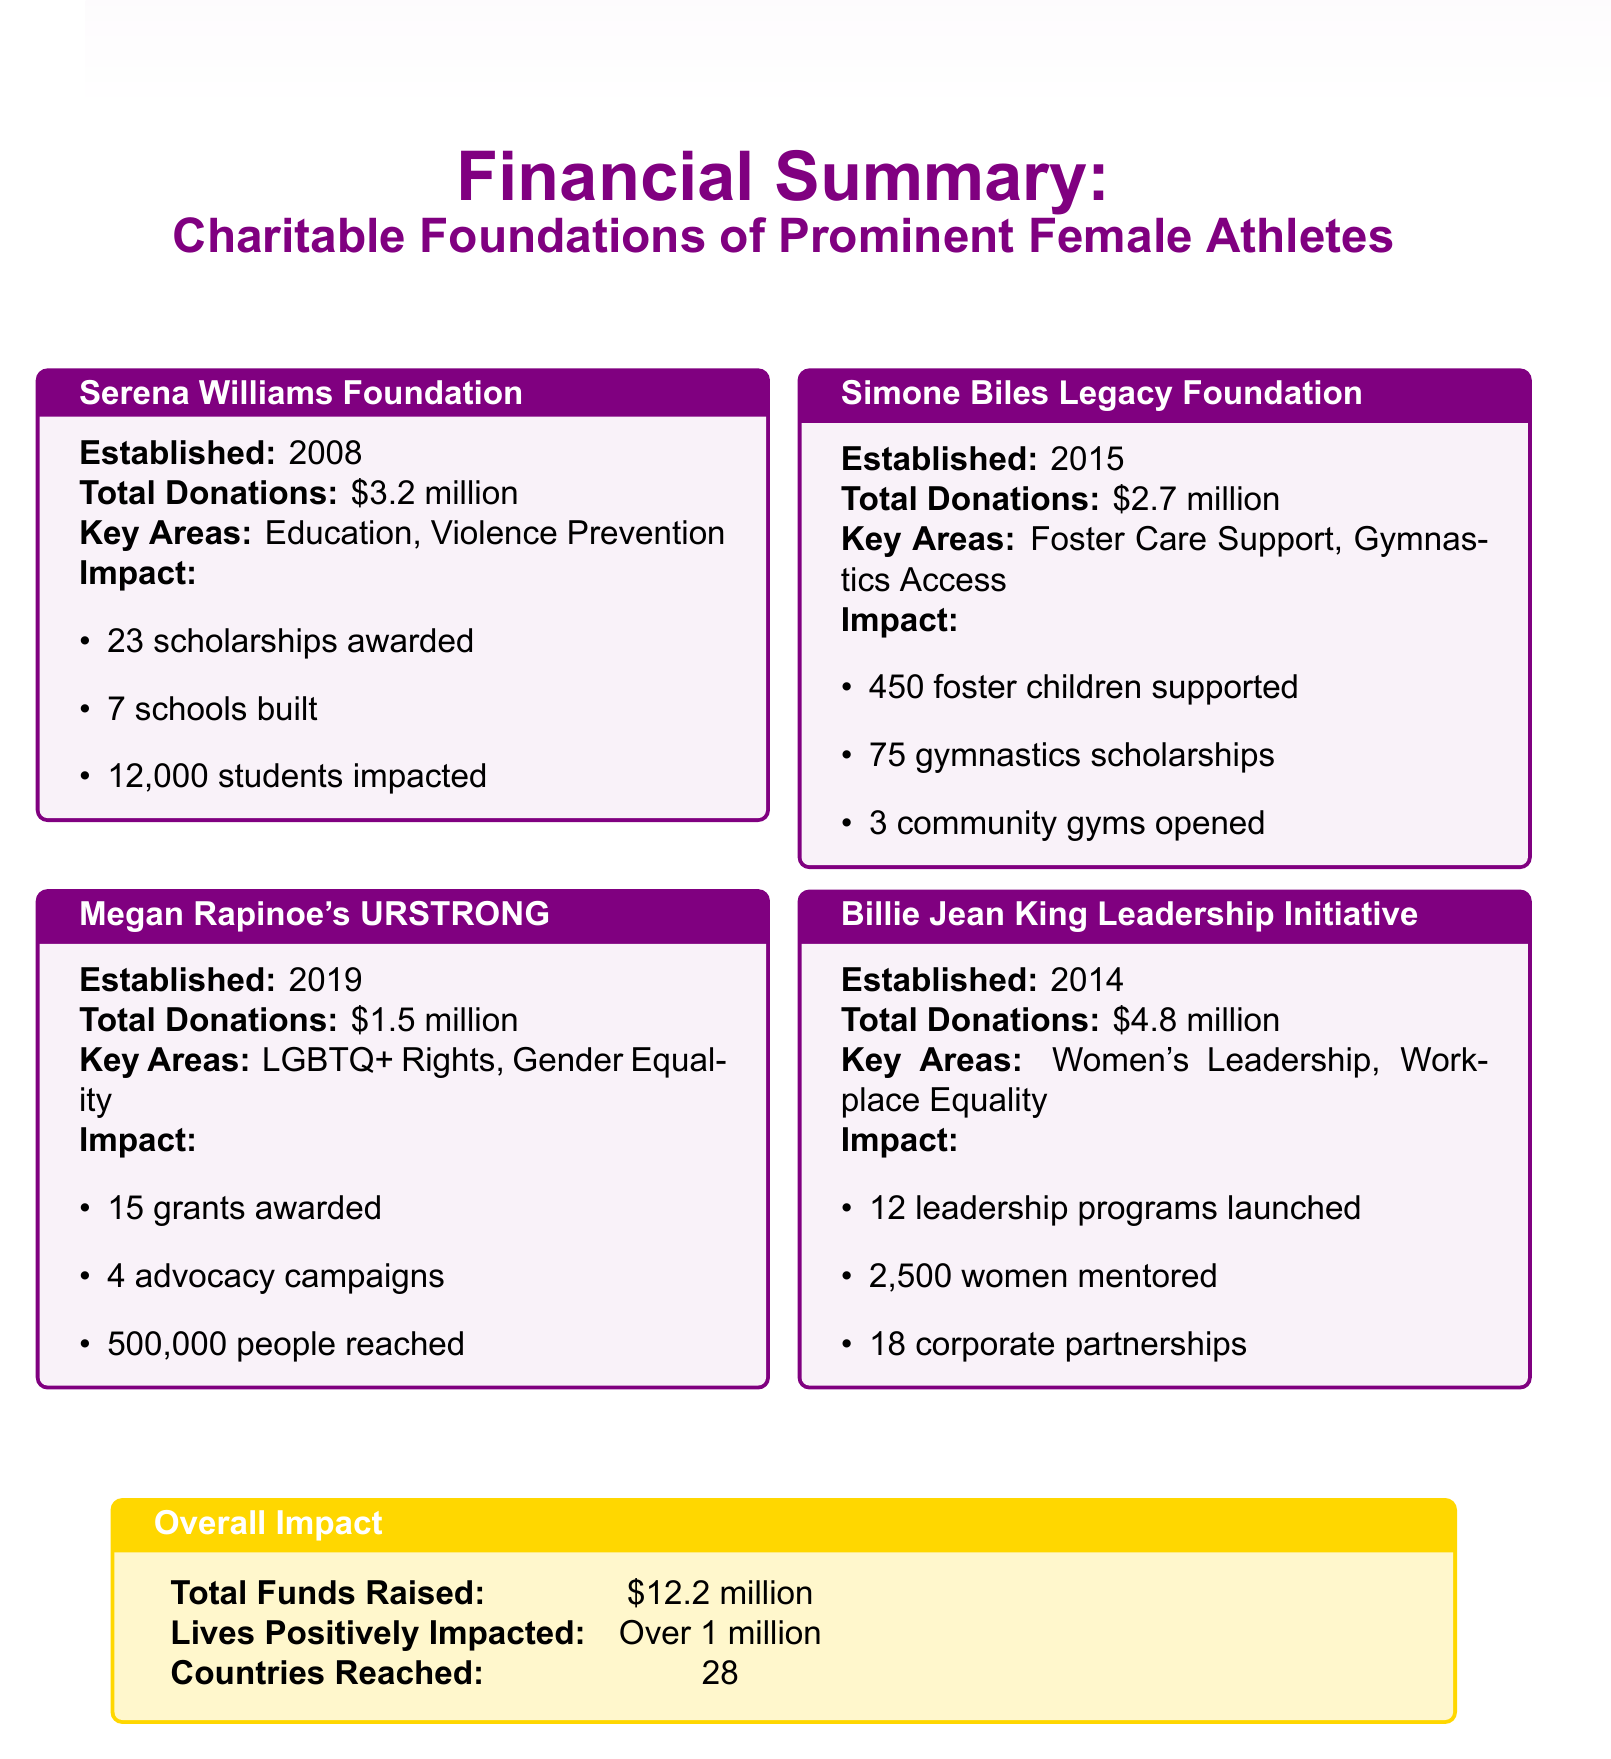What is the total amount of donations from the Billie Jean King Leadership Initiative? The total donations from the Billie Jean King Leadership Initiative are specified in the document as $4.8 million.
Answer: $4.8 million How many scholarships did the Serena Williams Foundation award? The document details that the Serena Williams Foundation awarded 23 scholarships.
Answer: 23 In what year was Megan Rapinoe's URSTRONG established? The document indicates that Megan Rapinoe's URSTRONG was established in the year 2019.
Answer: 2019 What is the total amount of funds raised by all foundations combined? According to the overall impact section, the total funds raised by all foundations is $12.2 million.
Answer: $12.2 million How many community gyms were opened by the Simone Biles Legacy Foundation? The document mentions that 3 community gyms were opened by the Simone Biles Legacy Foundation.
Answer: 3 What key area does the Billie Jean King Leadership Initiative focus on? The document states that a key area of focus for the Billie Jean King Leadership Initiative is Women's Leadership.
Answer: Women's Leadership How many countries have been reached collectively by all foundations? The overall impact section reports that the foundations have reached 28 countries.
Answer: 28 Which foundation has impacted over 1 million lives? The overall impact statement claims that all foundations combined have positively impacted over 1 million lives.
Answer: All foundations What is the total number of people reached by Megan Rapinoe's URSTRONG? The document provides the total number of people reached by Megan Rapinoe's URSTRONG as 500,000.
Answer: 500,000 